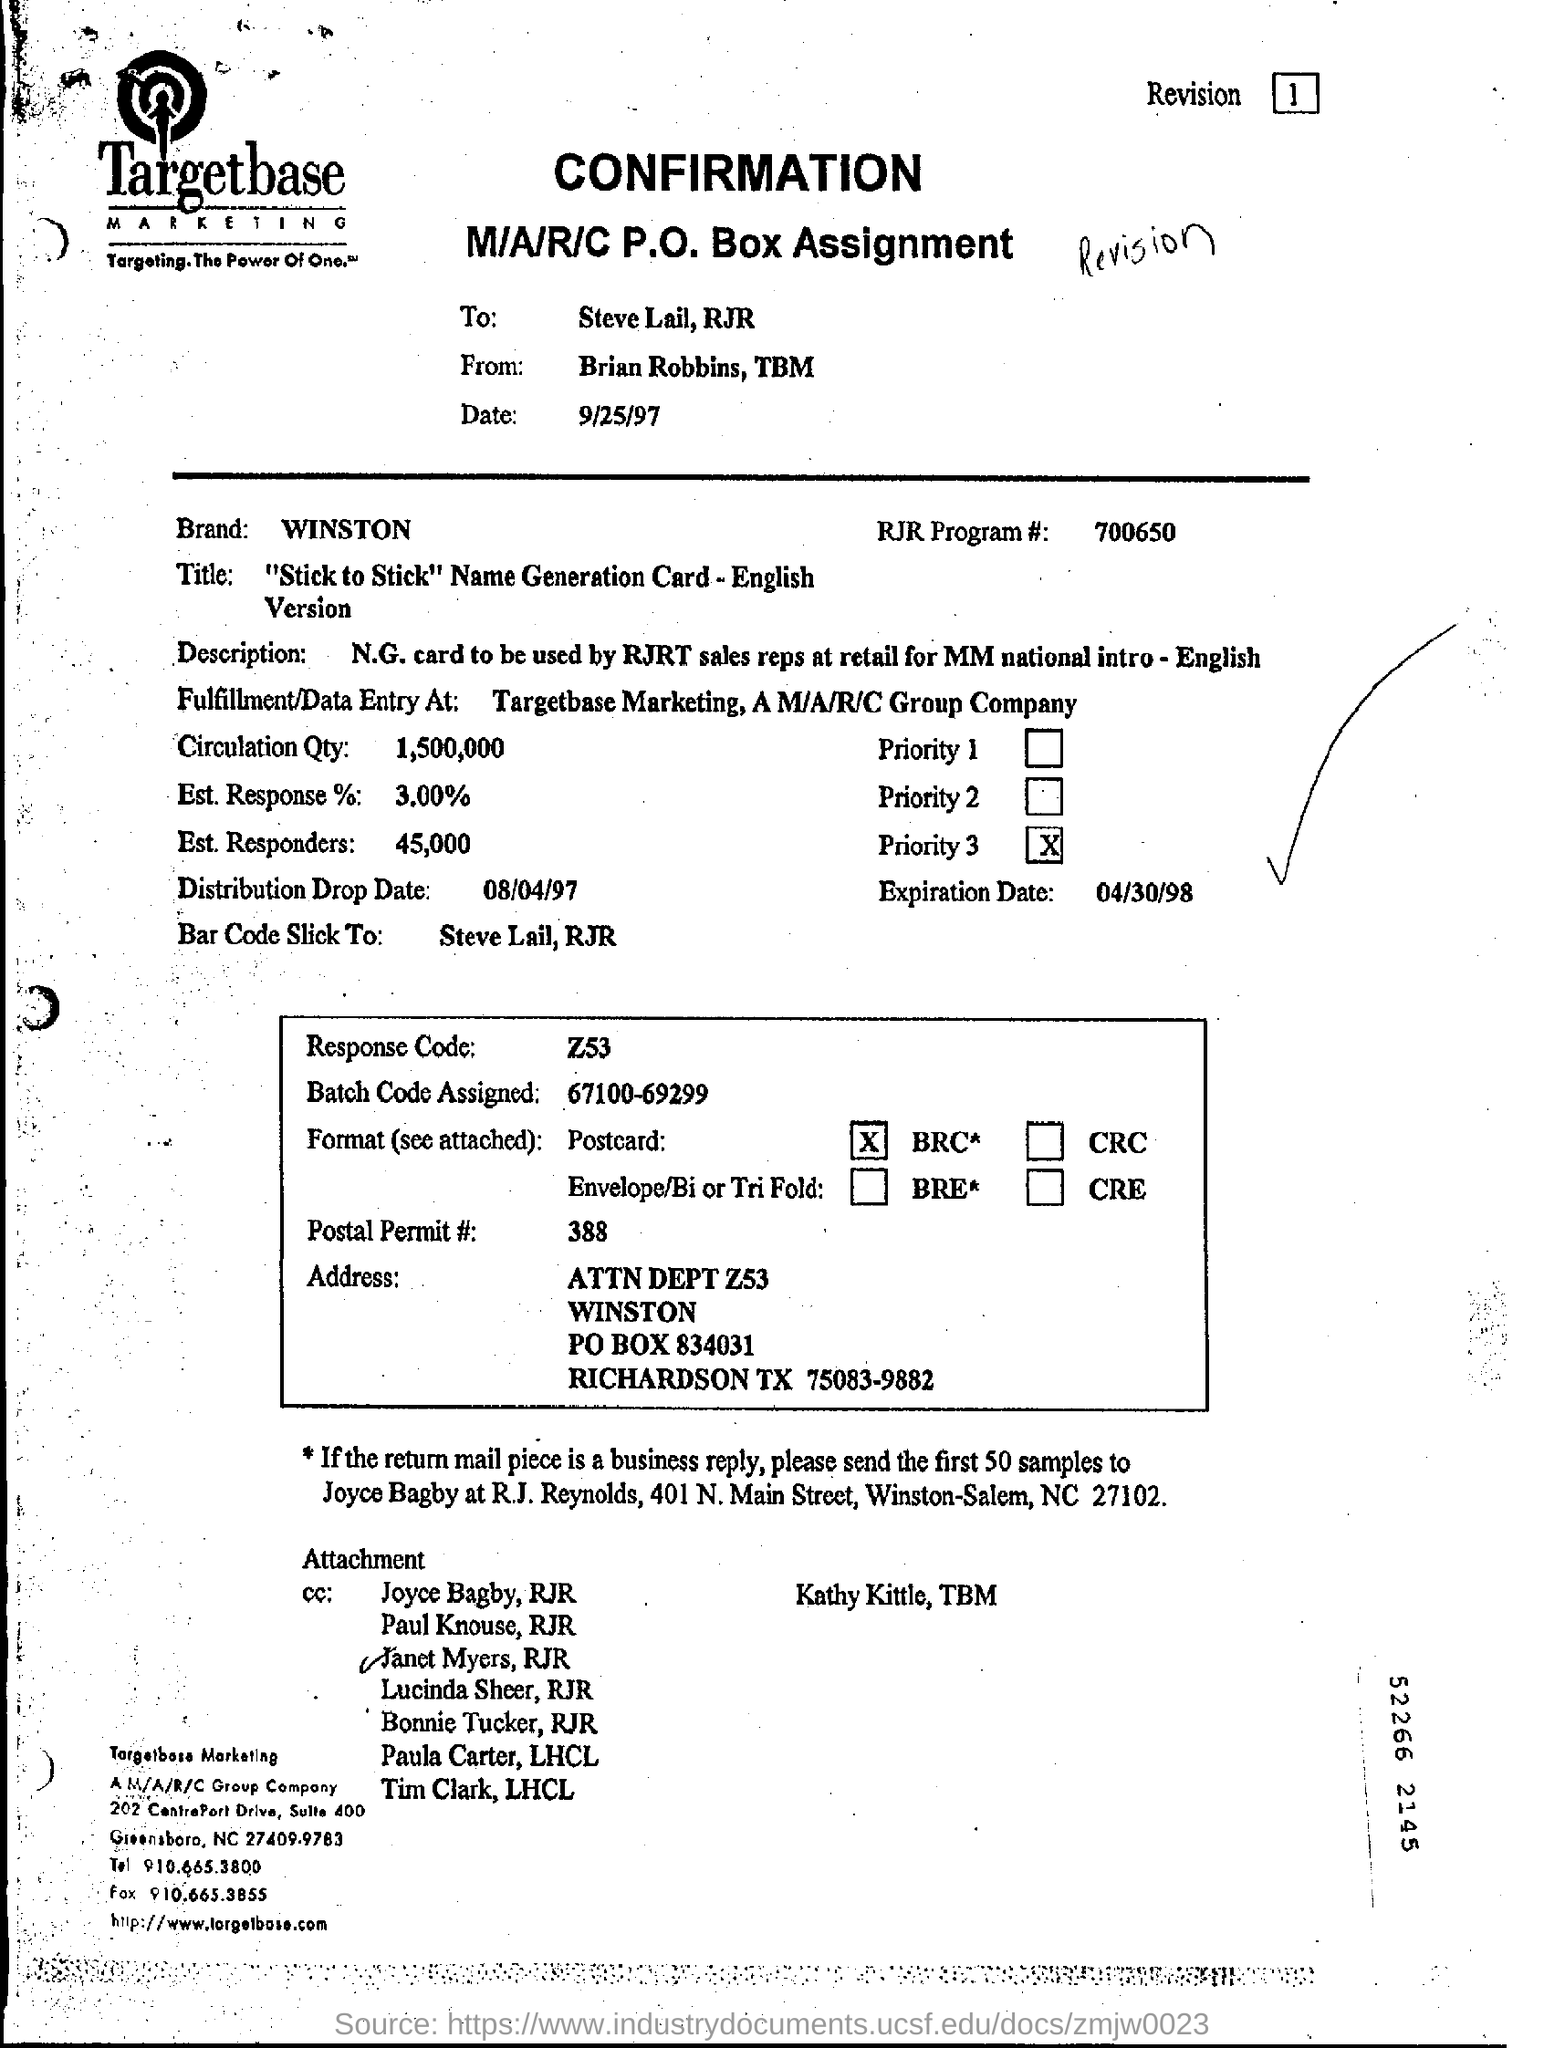Who is the sender of the confirmation from targetbase?
Offer a very short reply. Brian Robbins. What is the code of the response?
Keep it short and to the point. Z53. What is the rate of the est. response%?
Offer a terse response. 3.00. 